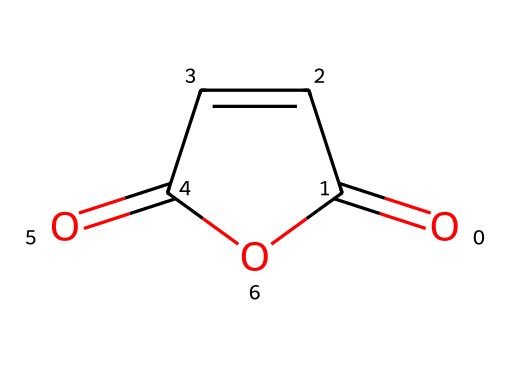What is the name of this chemical? The SMILES representation corresponds to maleic anhydride, which is a specific type of anhydride characterized by its unsaturated cyclic structure.
Answer: maleic anhydride How many carbon atoms are in maleic anhydride? By analyzing the SMILES structure, we count the number of carbon (C) symbols present, which shows there are four carbon atoms in total.
Answer: four How many oxygen atoms are in maleic anhydride? The SMILES structure includes the oxygen (O) atoms, and by identifying the O symbols, we see there are three oxygen atoms in total.
Answer: three What is the type of this chemical? Maleic anhydride belongs to the class of acid anhydrides, as indicated by its structure, which features an anhydride functional group connected to a double bond.
Answer: acid anhydride Is maleic anhydride cyclic or acyclic? The structural representation of maleic anhydride shows that it has a ring structure (as indicated by the ring notation in the SMILES), making it a cyclic compound.
Answer: cyclic What functional groups are present in maleic anhydride? The structure includes an anhydride functional group characterized by Carbonyl (C=O) components, shown in the cyclic structure with double bonds, and thus the functional groups are anhydride.
Answer: anhydride How many double bonds are there in maleic anhydride? By examining the structure, we observe that there are two carbon-carbon double bonds, which are indicated by the '=' sign in the SMILES representation.
Answer: two 